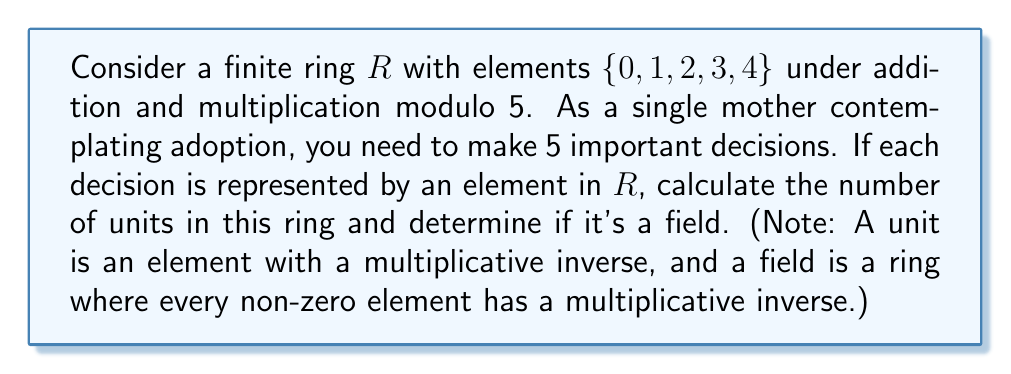Solve this math problem. To solve this problem, we need to follow these steps:

1. Identify the number of elements in the ring:
   The ring $R$ has 5 elements: $\{0, 1, 2, 3, 4\}$

2. Find the units of the ring:
   A unit is an element that has a multiplicative inverse. We need to check which elements, when multiplied by another element in the ring (modulo 5), result in 1.

   For 1: $1 \cdot 1 \equiv 1 \pmod{5}$, so 1 is a unit.
   For 2: $2 \cdot 3 \equiv 1 \pmod{5}$, so 2 is a unit (and 3 is its inverse).
   For 3: $3 \cdot 2 \equiv 1 \pmod{5}$, so 3 is a unit (and 2 is its inverse).
   For 4: $4 \cdot 4 \equiv 1 \pmod{5}$, so 4 is a unit.

   0 is not a unit as it has no multiplicative inverse.

3. Count the number of units:
   There are 4 units: 1, 2, 3, and 4.

4. Determine if it's a field:
   A field is a ring where every non-zero element has a multiplicative inverse. In this case, all non-zero elements (1, 2, 3, 4) have multiplicative inverses, so this ring is indeed a field.

This ring is actually the finite field $\mathbb{Z}_5$, also known as $GF(5)$ (Galois Field of order 5).
Answer: Number of units: 4
Is it a field? Yes 